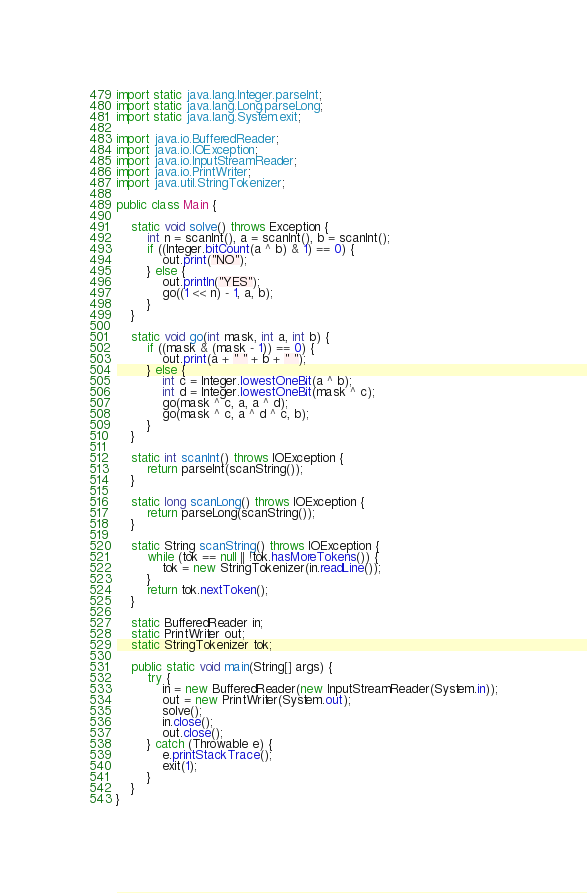Convert code to text. <code><loc_0><loc_0><loc_500><loc_500><_Java_>import static java.lang.Integer.parseInt;
import static java.lang.Long.parseLong;
import static java.lang.System.exit;

import java.io.BufferedReader;
import java.io.IOException;
import java.io.InputStreamReader;
import java.io.PrintWriter;
import java.util.StringTokenizer;

public class Main {

	static void solve() throws Exception {
		int n = scanInt(), a = scanInt(), b = scanInt();
		if ((Integer.bitCount(a ^ b) & 1) == 0) {
			out.print("NO");
		} else {
			out.println("YES");
			go((1 << n) - 1, a, b);
		}
	}

	static void go(int mask, int a, int b) {
		if ((mask & (mask - 1)) == 0) {
			out.print(a + " " + b + " ");
		} else {
			int c = Integer.lowestOneBit(a ^ b);
			int d = Integer.lowestOneBit(mask ^ c);
			go(mask ^ c, a, a ^ d);
			go(mask ^ c, a ^ d ^ c, b);
		}
	}

	static int scanInt() throws IOException {
		return parseInt(scanString());
	}

	static long scanLong() throws IOException {
		return parseLong(scanString());
	}

	static String scanString() throws IOException {
		while (tok == null || !tok.hasMoreTokens()) {
			tok = new StringTokenizer(in.readLine());
		}
		return tok.nextToken();
	}

	static BufferedReader in;
	static PrintWriter out;
	static StringTokenizer tok;

	public static void main(String[] args) {
		try {
			in = new BufferedReader(new InputStreamReader(System.in));
			out = new PrintWriter(System.out);
			solve();
			in.close();
			out.close();
		} catch (Throwable e) {
			e.printStackTrace();
			exit(1);
		}
	}
}</code> 